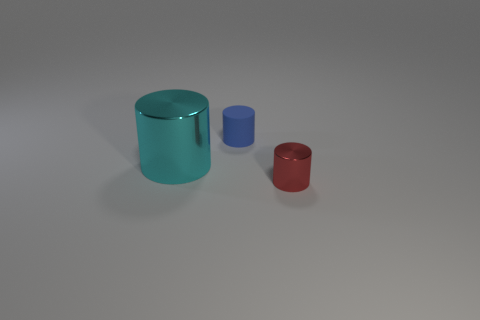Subtract all small red metallic cylinders. How many cylinders are left? 2 Add 3 small red metallic cylinders. How many objects exist? 6 Subtract all brown cylinders. Subtract all blue spheres. How many cylinders are left? 3 Subtract all metal cylinders. Subtract all tiny blue matte cylinders. How many objects are left? 0 Add 1 tiny blue cylinders. How many tiny blue cylinders are left? 2 Add 1 small blue spheres. How many small blue spheres exist? 1 Subtract 0 green cylinders. How many objects are left? 3 